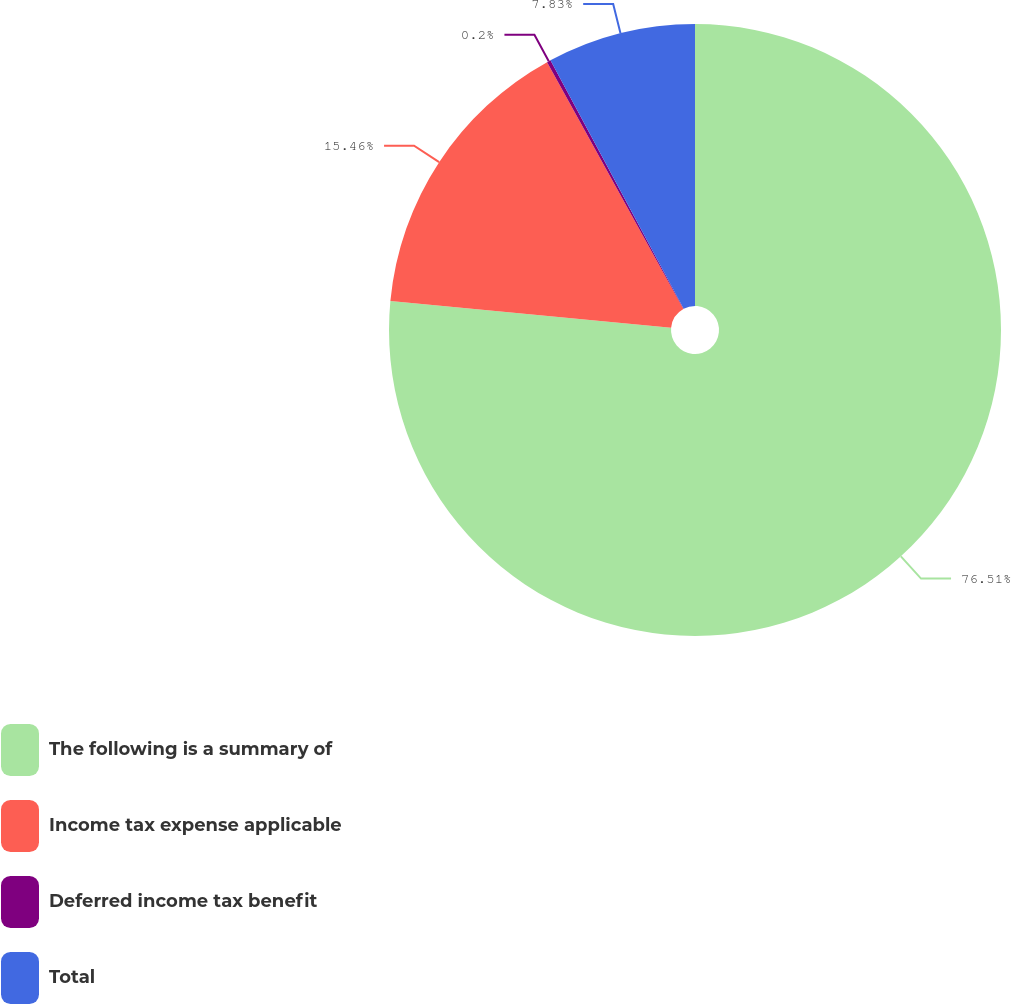<chart> <loc_0><loc_0><loc_500><loc_500><pie_chart><fcel>The following is a summary of<fcel>Income tax expense applicable<fcel>Deferred income tax benefit<fcel>Total<nl><fcel>76.51%<fcel>15.46%<fcel>0.2%<fcel>7.83%<nl></chart> 